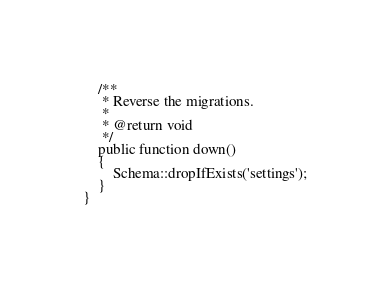Convert code to text. <code><loc_0><loc_0><loc_500><loc_500><_PHP_>    /**
     * Reverse the migrations.
     *
     * @return void
     */
    public function down()
    {
        Schema::dropIfExists('settings');
    }
}
</code> 